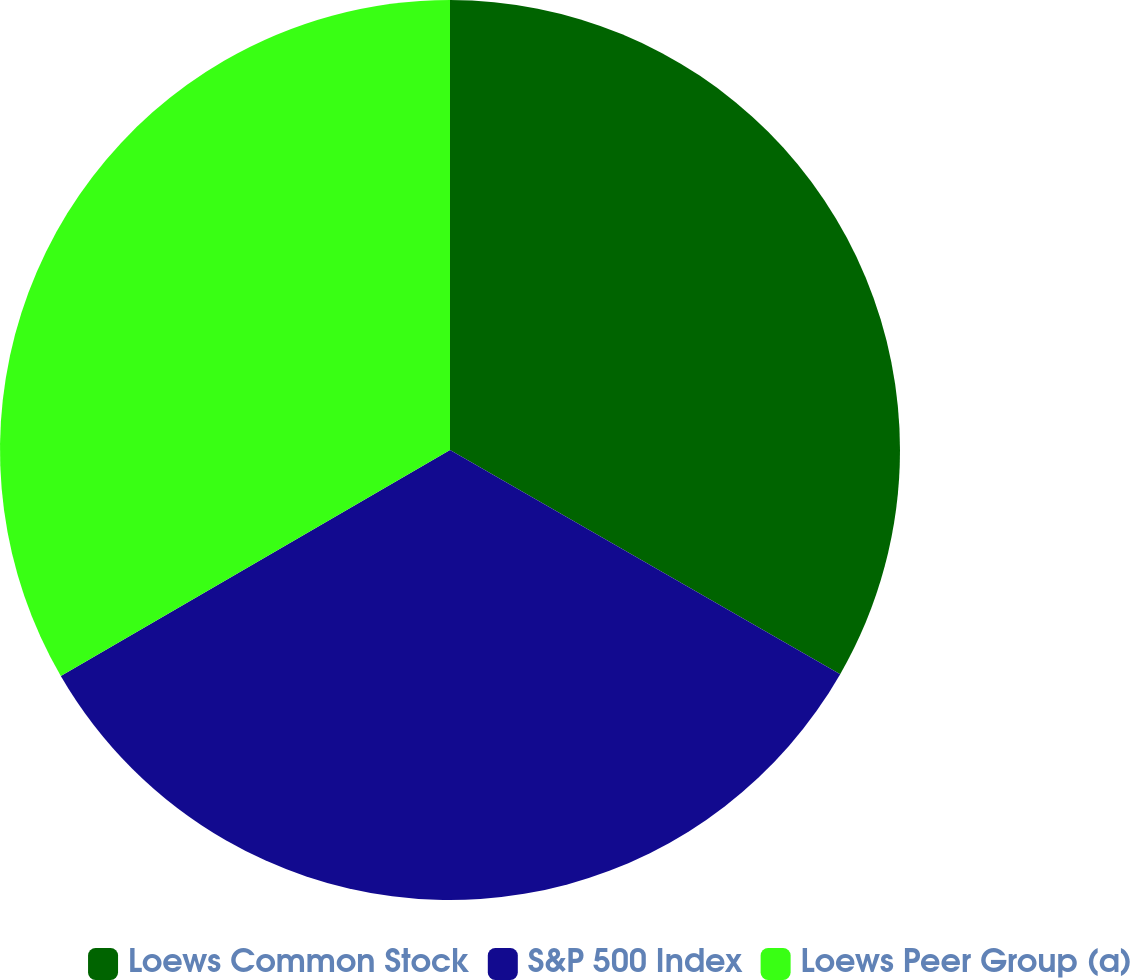<chart> <loc_0><loc_0><loc_500><loc_500><pie_chart><fcel>Loews Common Stock<fcel>S&P 500 Index<fcel>Loews Peer Group (a)<nl><fcel>33.3%<fcel>33.33%<fcel>33.37%<nl></chart> 